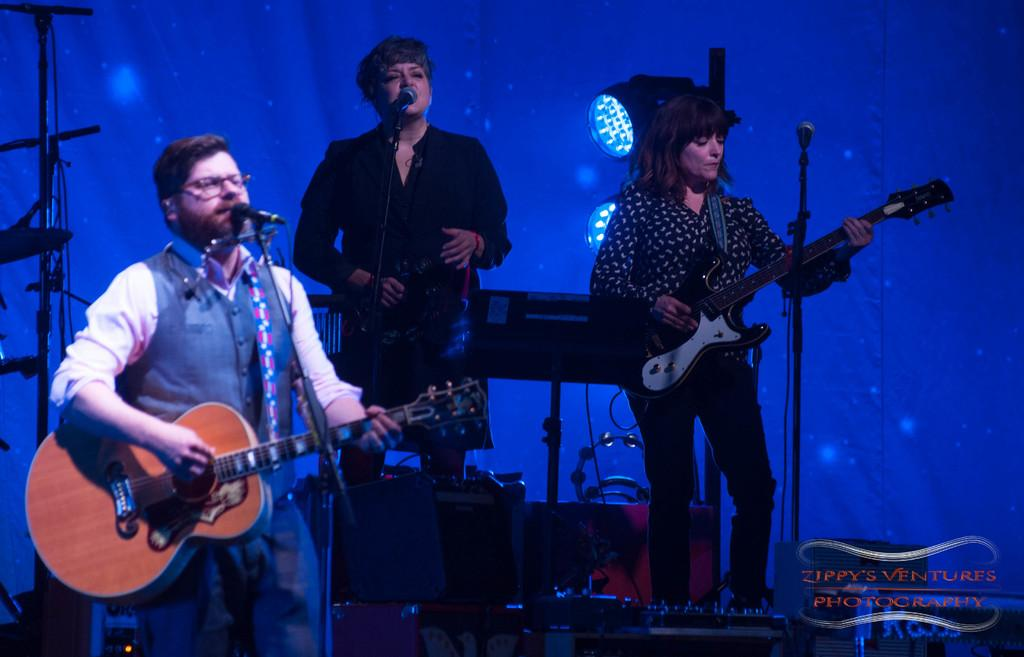How many people are in the image? There are two persons standing in the image. What is one of the persons doing? One of the persons is playing a guitar. Can you describe the background of the image? There is another person standing in the background, along with a piano and a stand. What type of lighting is visible in the image? Focus lights are visible in the image. How much debt does the person playing the guitar have in the image? There is no information about the person's debt in the image. Can you describe the bite marks on the guitar in the image? There are no bite marks visible on the guitar in the image. 